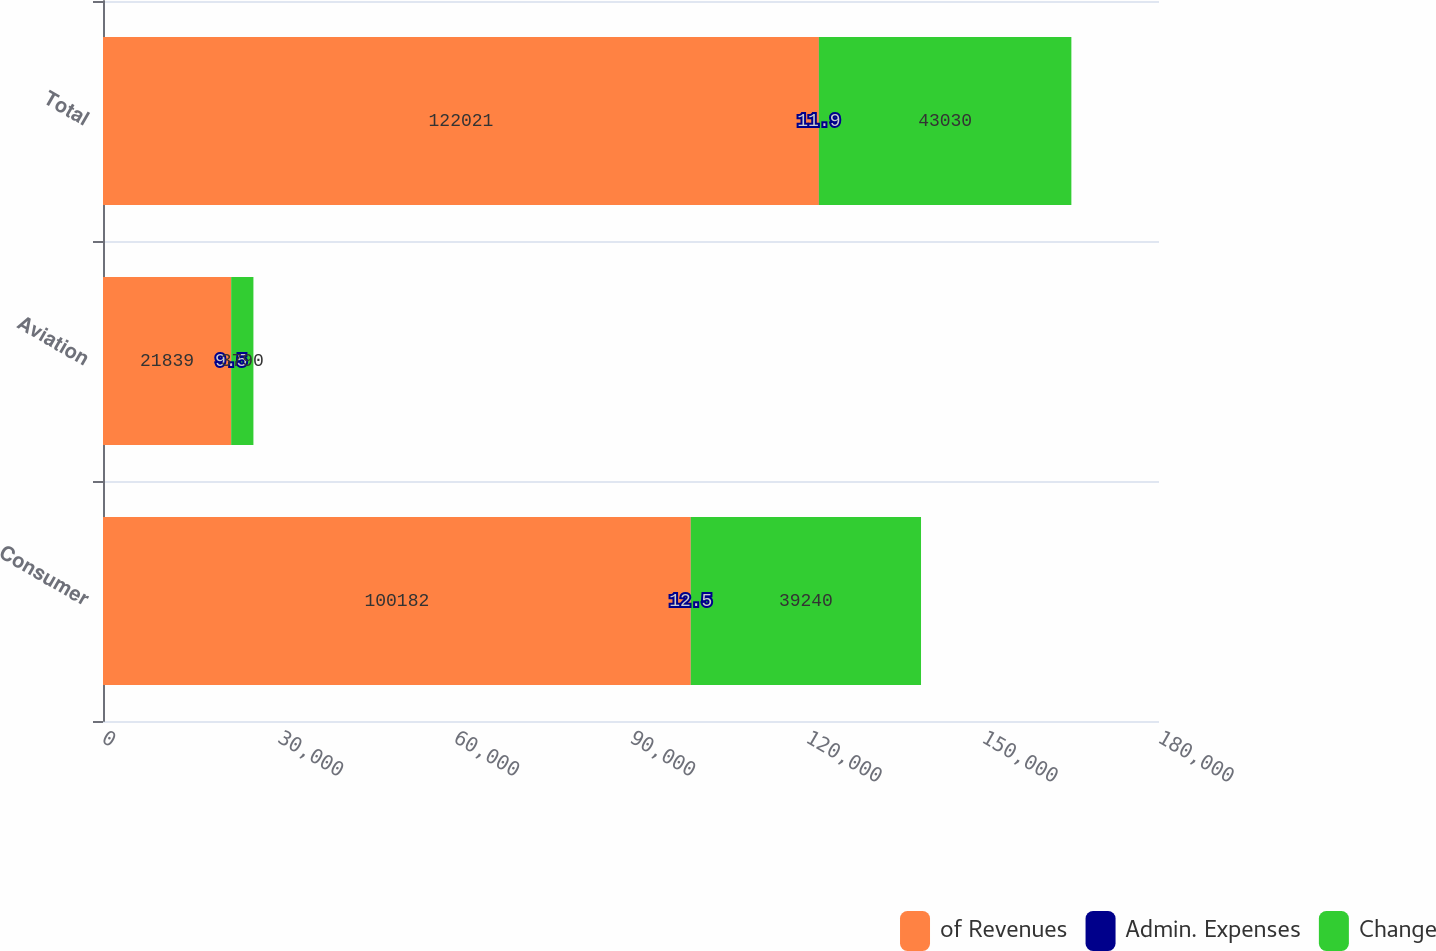Convert chart. <chart><loc_0><loc_0><loc_500><loc_500><stacked_bar_chart><ecel><fcel>Consumer<fcel>Aviation<fcel>Total<nl><fcel>of Revenues<fcel>100182<fcel>21839<fcel>122021<nl><fcel>Admin. Expenses<fcel>12.5<fcel>9.5<fcel>11.9<nl><fcel>Change<fcel>39240<fcel>3790<fcel>43030<nl></chart> 